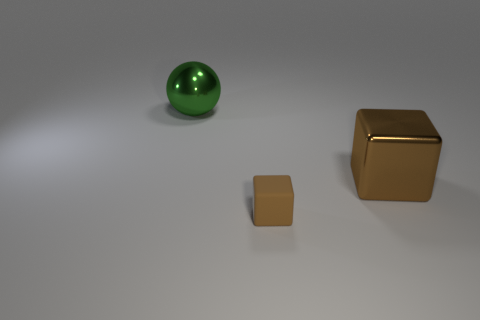Add 1 large shiny balls. How many objects exist? 4 Subtract all cubes. How many objects are left? 1 Add 3 big cubes. How many big cubes exist? 4 Subtract 0 yellow cylinders. How many objects are left? 3 Subtract all balls. Subtract all rubber things. How many objects are left? 1 Add 3 shiny balls. How many shiny balls are left? 4 